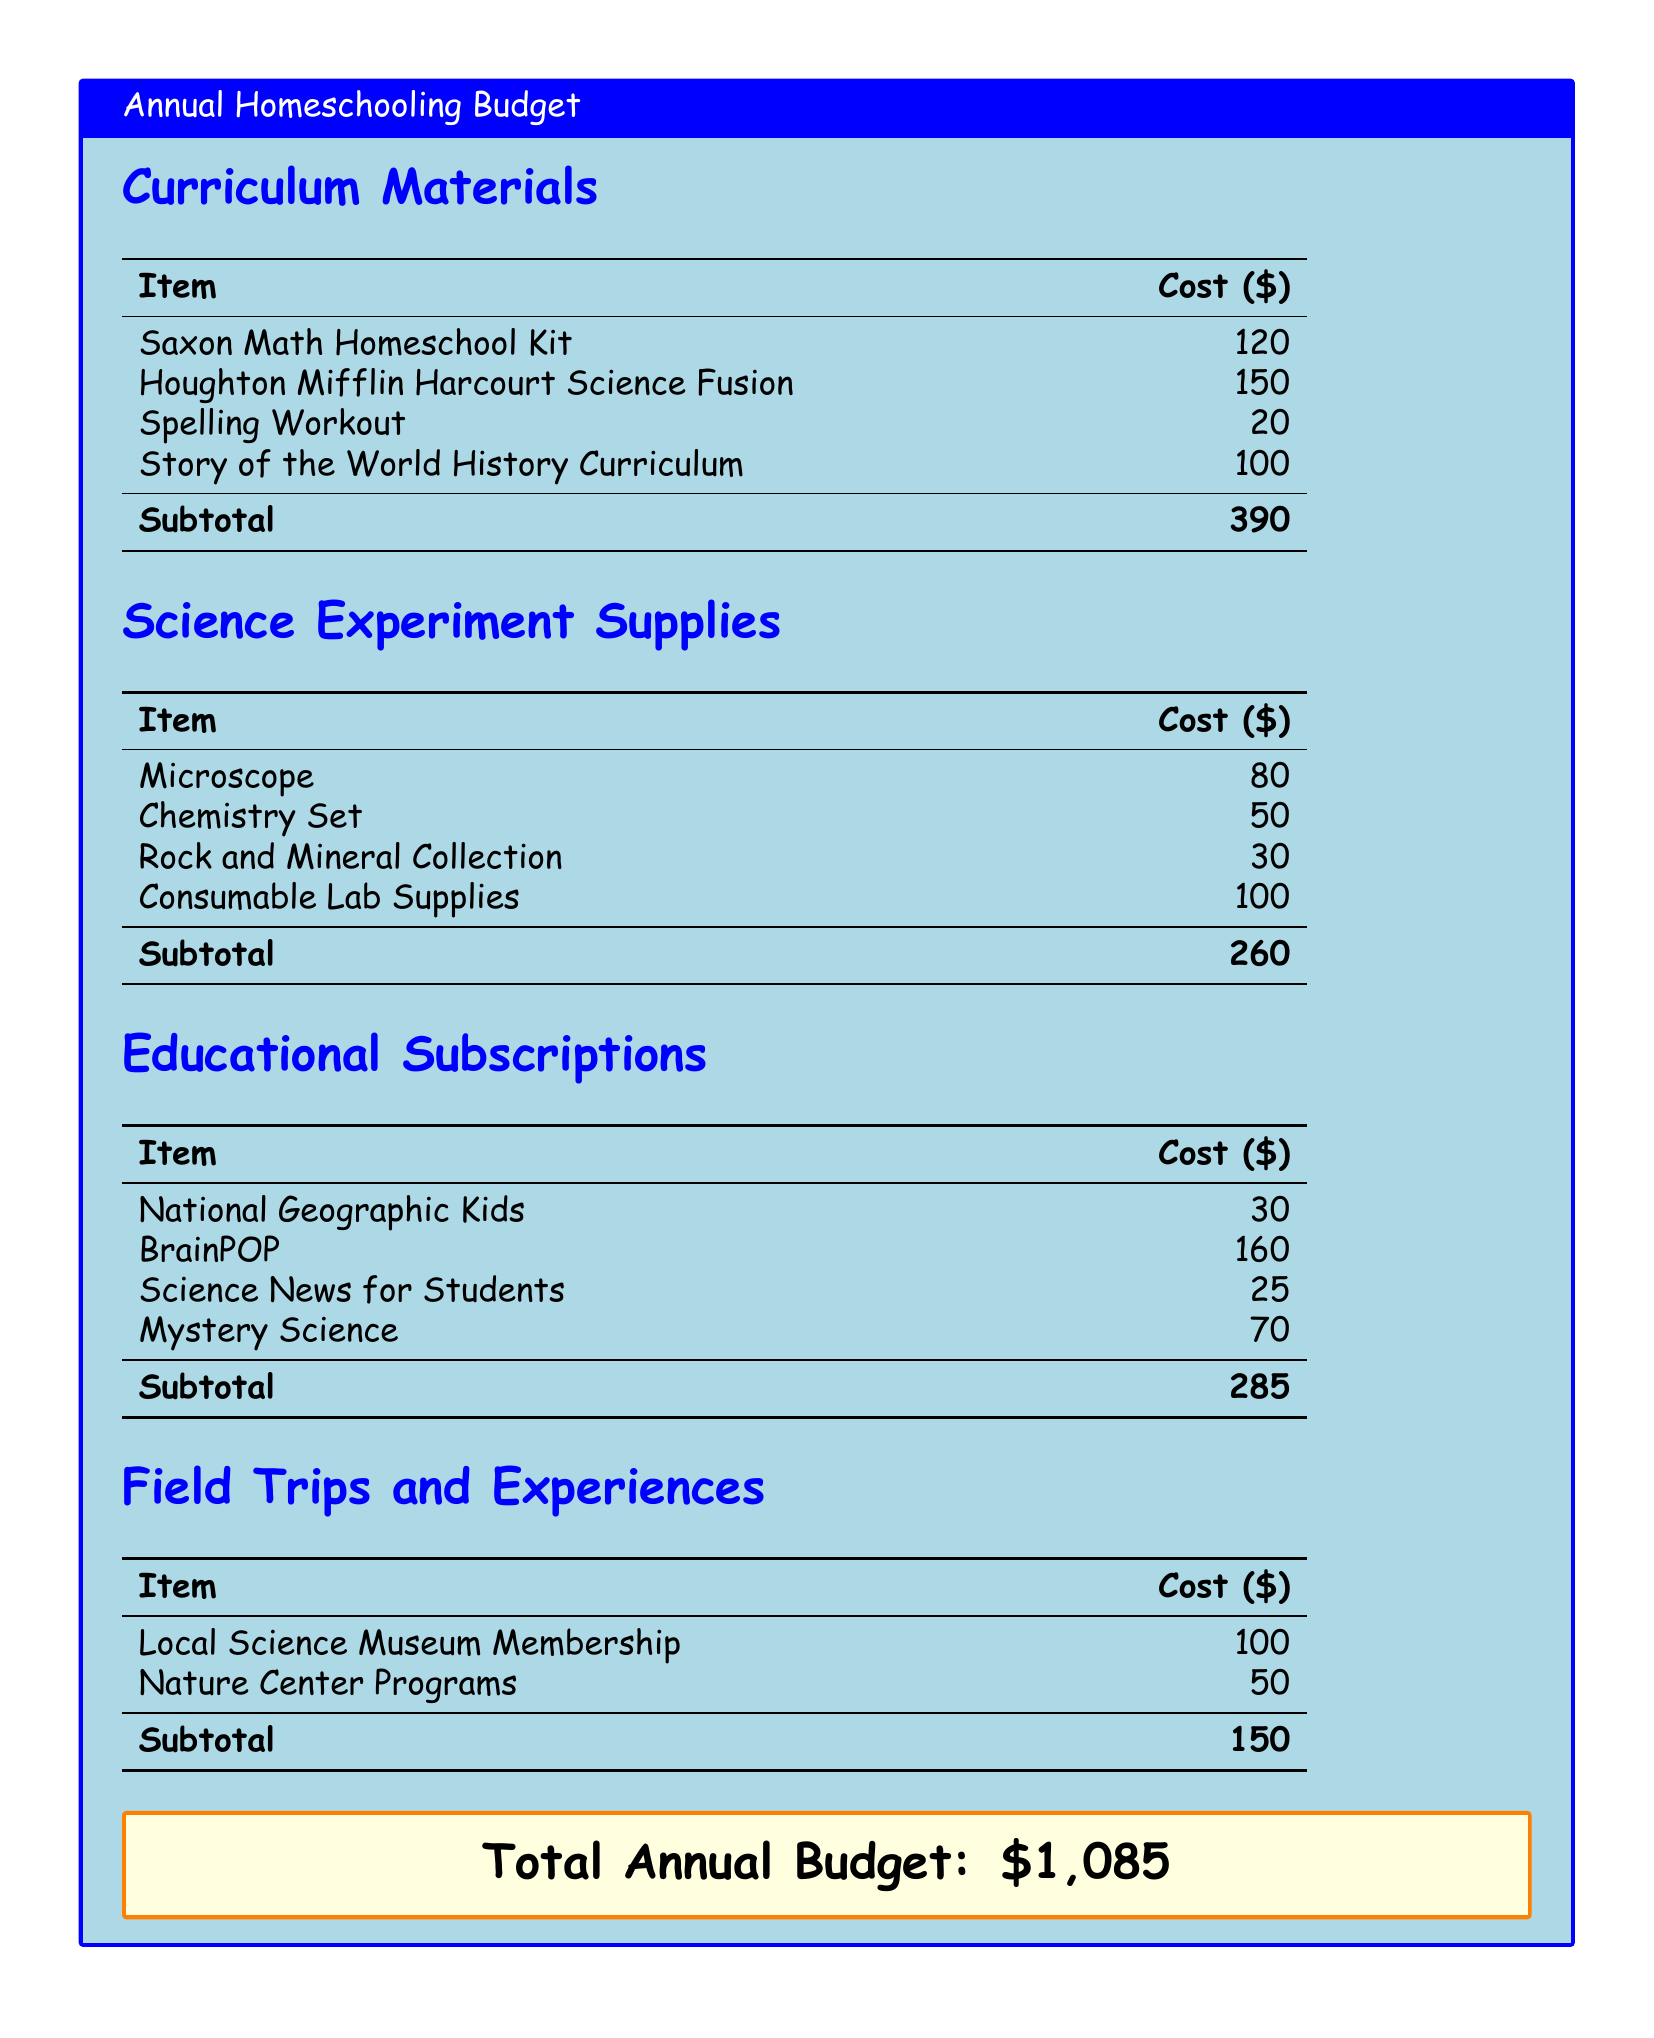What is the total annual budget? The total annual budget is given at the end of the document, which is $1,085.
Answer: $1,085 How much does the Saxon Math Homeschool Kit cost? The cost of the Saxon Math Homeschool Kit is listed under Curriculum Materials as $120.
Answer: $120 What is the subtotal for Science Experiment Supplies? The subtotal for Science Experiment Supplies is calculated from the individual items listed, equaling $260.
Answer: $260 Which educational subscription costs the most? By comparing the listed prices, BrainPOP is the most expensive educational subscription at $160.
Answer: BrainPOP What is the cost of the Local Science Museum Membership? The cost of the Local Science Museum Membership is found in the Field Trips and Experiences section and is $100.
Answer: $100 How many categories are there in the budget? The document lists four categories: Curriculum Materials, Science Experiment Supplies, Educational Subscriptions, and Field Trips and Experiences.
Answer: Four What is the cost of the chemistry set? The chemistry set's price is listed as $50 under the Science Experiment Supplies section.
Answer: $50 What is the total cost of educational subscriptions? The total cost of educational subscriptions is the sum of the listed items, which equals $285.
Answer: $285 Which item has a cost of $30 in the Science Experiment Supplies section? There is no item with that price there; however, the Rock and Mineral Collection is priced at $30.
Answer: Rock and Mineral Collection 